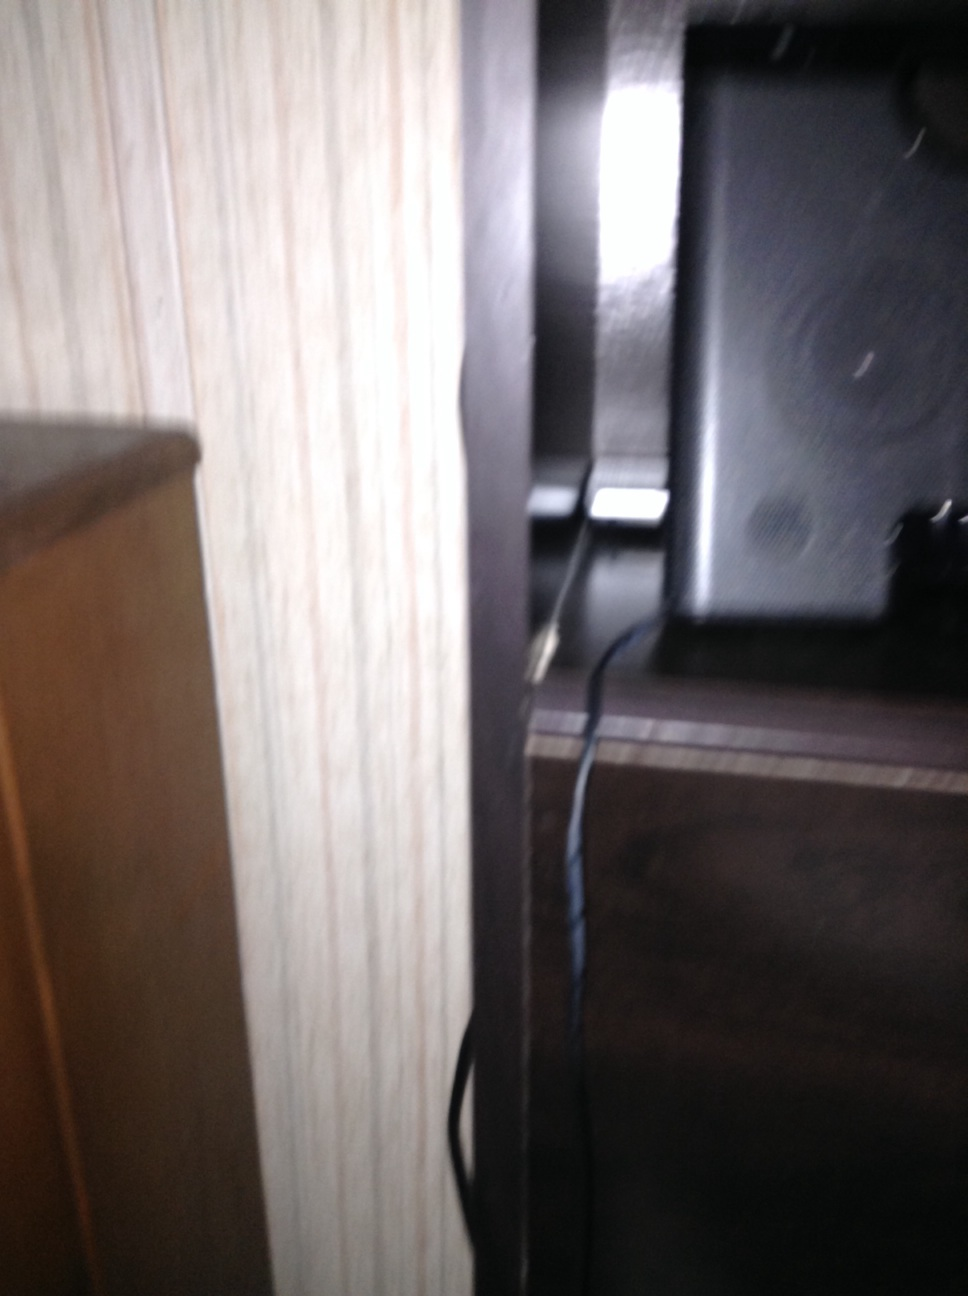What is that? The image depicts part of a room with a speaker partially visible on the right side, placed on a shelf with wires connected to it. The speaker seems to be set up next to a wooden furniture item on the left. 